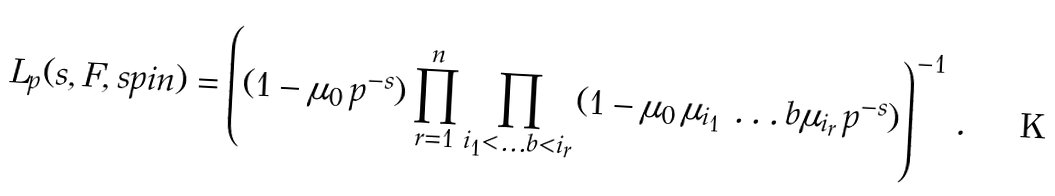Convert formula to latex. <formula><loc_0><loc_0><loc_500><loc_500>L _ { p } ( s , F , s p i n ) = \left ( ( 1 - \mu _ { 0 } \, p ^ { - s } ) \prod _ { r = 1 } ^ { n } \prod _ { i _ { 1 } < \dots b < i _ { r } } ( 1 - \mu _ { 0 } \, \mu _ { i _ { 1 } } \, \dots b \mu _ { i _ { r } } \, p ^ { - s } ) \right ) ^ { - 1 } \, .</formula> 